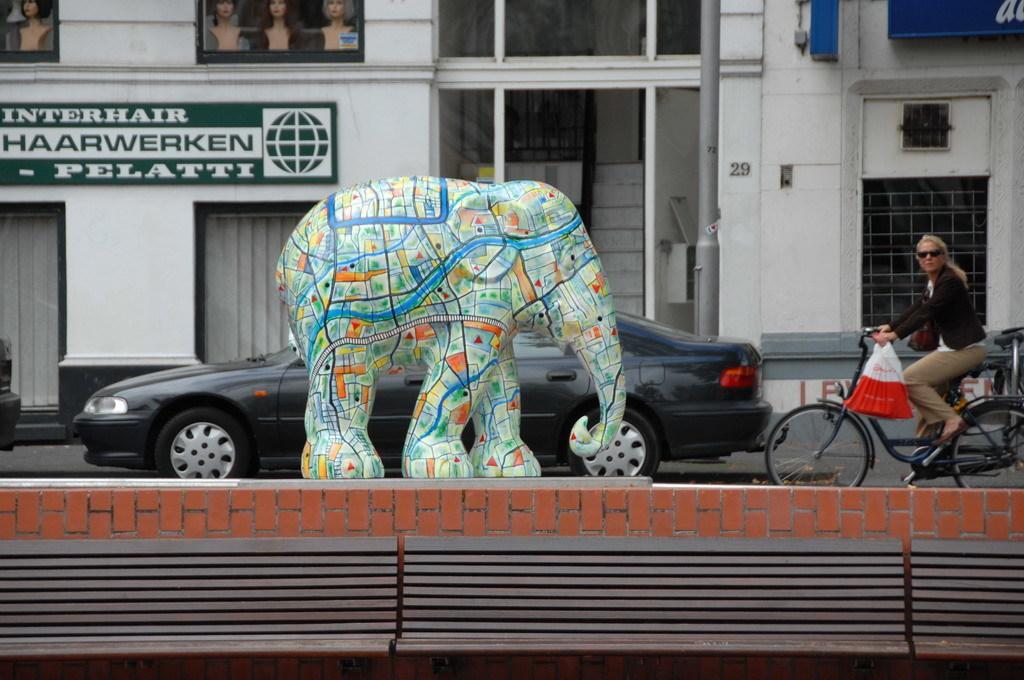Please provide a concise description of this image. In this picture there is a Elephant statue and there is a car behind it, also a bicycle and a woman riding it 